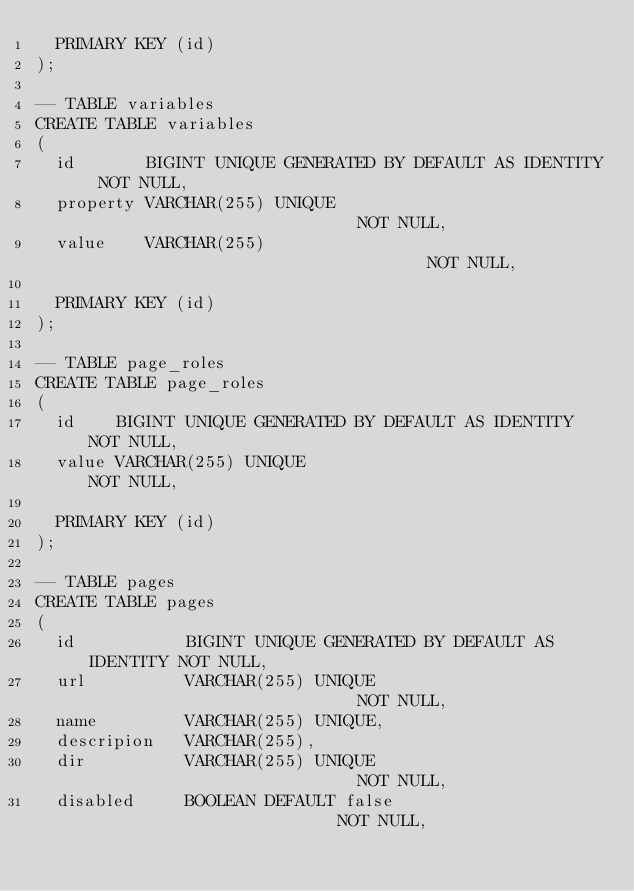Convert code to text. <code><loc_0><loc_0><loc_500><loc_500><_SQL_>  PRIMARY KEY (id)
);

-- TABLE variables
CREATE TABLE variables
(
  id       BIGINT UNIQUE GENERATED BY DEFAULT AS IDENTITY NOT NULL,
  property VARCHAR(255) UNIQUE                            NOT NULL,
  value    VARCHAR(255)                                   NOT NULL,

  PRIMARY KEY (id)
);

-- TABLE page_roles
CREATE TABLE page_roles
(
  id    BIGINT UNIQUE GENERATED BY DEFAULT AS IDENTITY NOT NULL,
  value VARCHAR(255) UNIQUE                            NOT NULL,

  PRIMARY KEY (id)
);

-- TABLE pages
CREATE TABLE pages
(
  id           BIGINT UNIQUE GENERATED BY DEFAULT AS IDENTITY NOT NULL,
  url          VARCHAR(255) UNIQUE                            NOT NULL,
  name         VARCHAR(255) UNIQUE,
  descripion   VARCHAR(255),
  dir          VARCHAR(255) UNIQUE                            NOT NULL,
  disabled     BOOLEAN DEFAULT false                          NOT NULL,</code> 